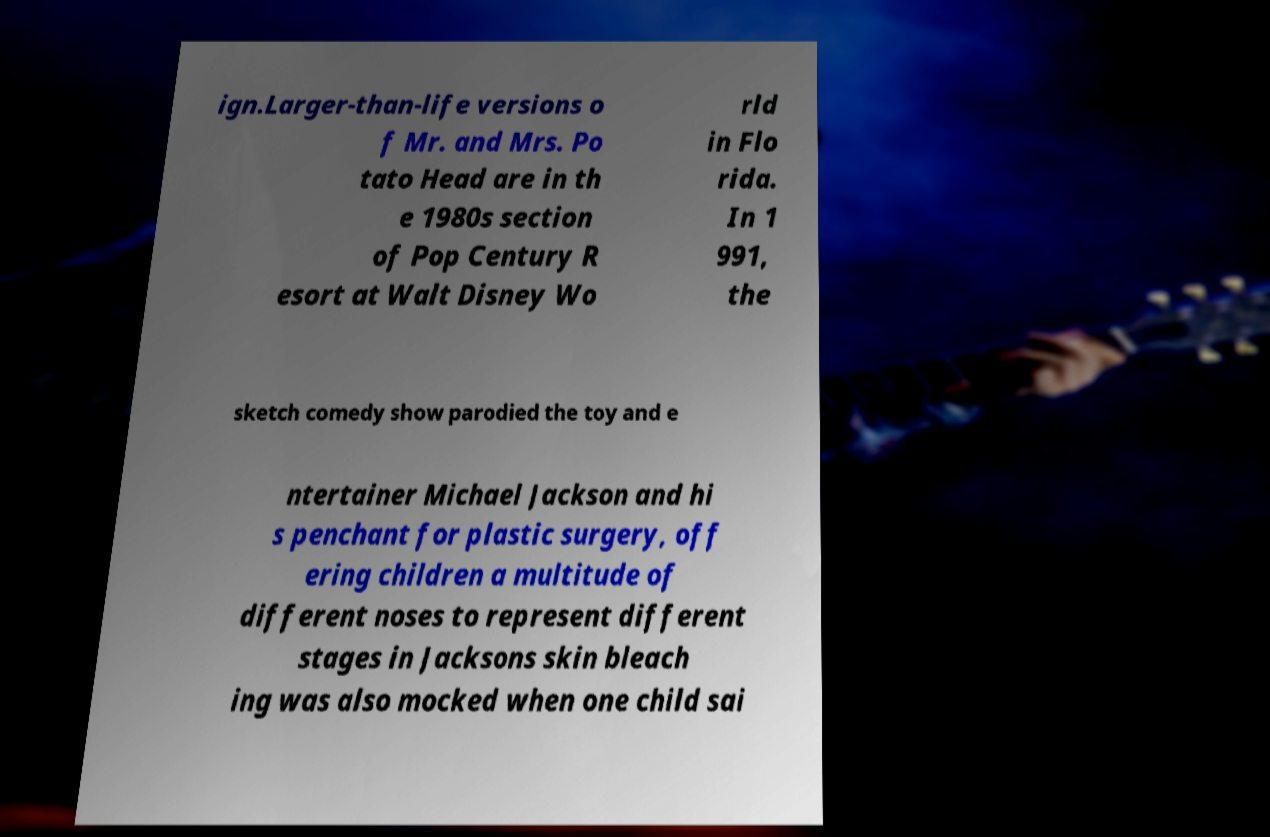For documentation purposes, I need the text within this image transcribed. Could you provide that? ign.Larger-than-life versions o f Mr. and Mrs. Po tato Head are in th e 1980s section of Pop Century R esort at Walt Disney Wo rld in Flo rida. In 1 991, the sketch comedy show parodied the toy and e ntertainer Michael Jackson and hi s penchant for plastic surgery, off ering children a multitude of different noses to represent different stages in Jacksons skin bleach ing was also mocked when one child sai 